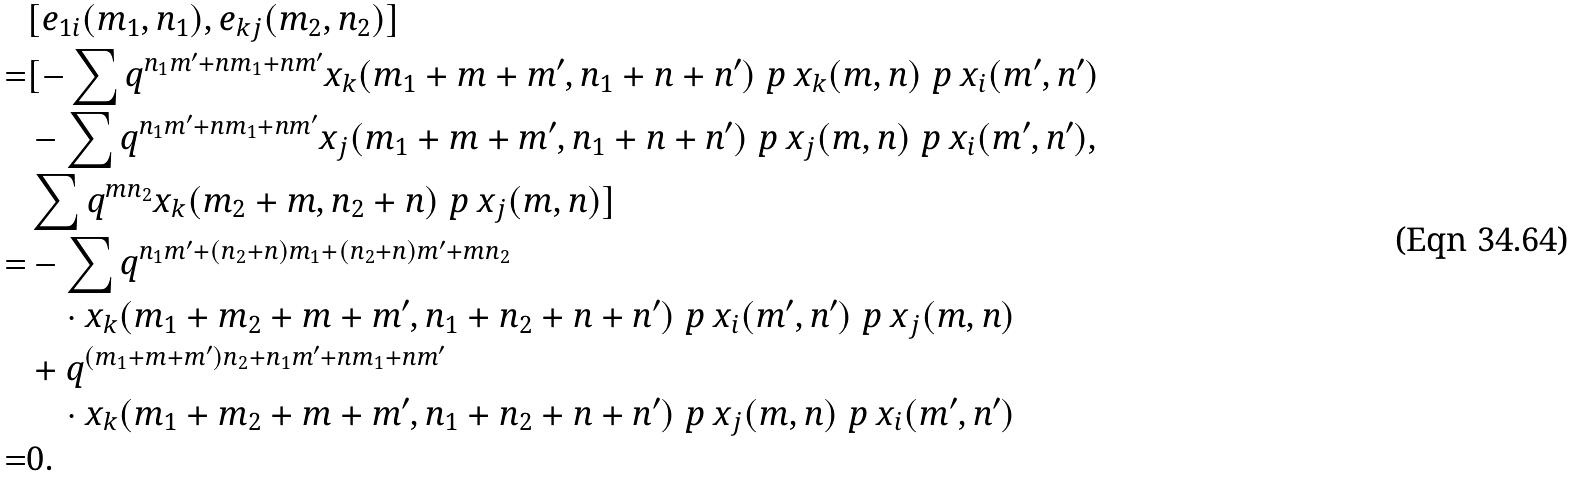Convert formula to latex. <formula><loc_0><loc_0><loc_500><loc_500>& [ e _ { 1 i } ( m _ { 1 } , n _ { 1 } ) , e _ { k j } ( m _ { 2 } , n _ { 2 } ) ] \\ = & [ - \sum q ^ { n _ { 1 } m ^ { \prime } + n m _ { 1 } + n m ^ { \prime } } x _ { k } ( m _ { 1 } + m + m ^ { \prime } , n _ { 1 } + n + n ^ { \prime } ) \ p { \ x _ { k } ( m , n ) } \ p { \ x _ { i } ( m ^ { \prime } , n ^ { \prime } ) } \\ & - \sum q ^ { n _ { 1 } m ^ { \prime } + n m _ { 1 } + n m ^ { \prime } } x _ { j } ( m _ { 1 } + m + m ^ { \prime } , n _ { 1 } + n + n ^ { \prime } ) \ p { \ x _ { j } ( m , n ) } \ p { \ x _ { i } ( m ^ { \prime } , n ^ { \prime } ) } , \\ & \sum q ^ { m n _ { 2 } } x _ { k } ( m _ { 2 } + m , n _ { 2 } + n ) \ p { \ x _ { j } ( m , n ) } ] \\ = & - \sum q ^ { n _ { 1 } m ^ { \prime } + ( n _ { 2 } + n ) m _ { 1 } + ( n _ { 2 } + n ) m ^ { \prime } + m n _ { 2 } } \\ & \quad \cdot x _ { k } ( m _ { 1 } + m _ { 2 } + m + m ^ { \prime } , n _ { 1 } + n _ { 2 } + n + n ^ { \prime } ) \ p { \ x _ { i } ( m ^ { \prime } , n ^ { \prime } ) } \ p { \ x _ { j } ( m , n ) } \\ & + q ^ { ( m _ { 1 } + m + m ^ { \prime } ) n _ { 2 } + n _ { 1 } m ^ { \prime } + n m _ { 1 } + n m ^ { \prime } } \\ & \quad \cdot x _ { k } ( m _ { 1 } + m _ { 2 } + m + m ^ { \prime } , n _ { 1 } + n _ { 2 } + n + n ^ { \prime } ) \ p { \ x _ { j } ( m , n ) } \ p { \ x _ { i } ( m ^ { \prime } , n ^ { \prime } ) } \\ = & 0 .</formula> 